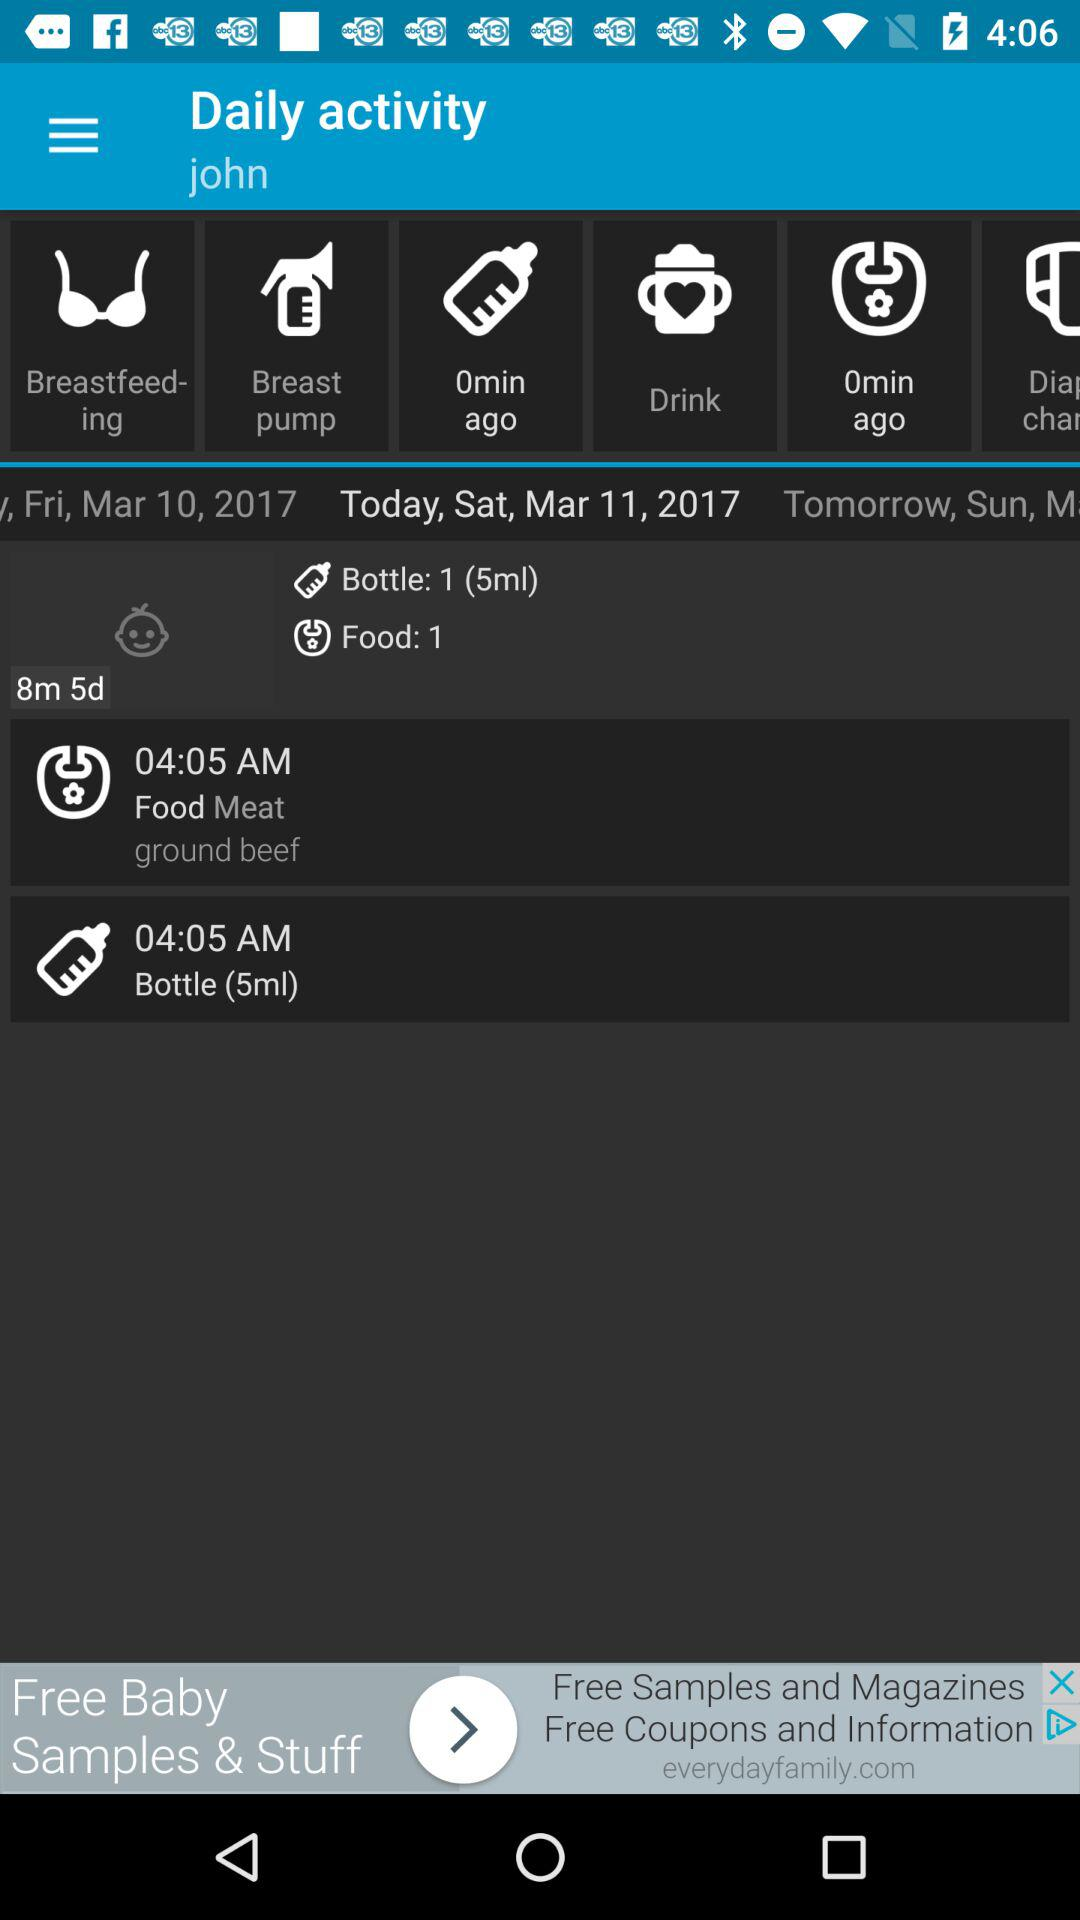What quantity is present in the bottle? The quantity present in the bottle is 5 ml. 